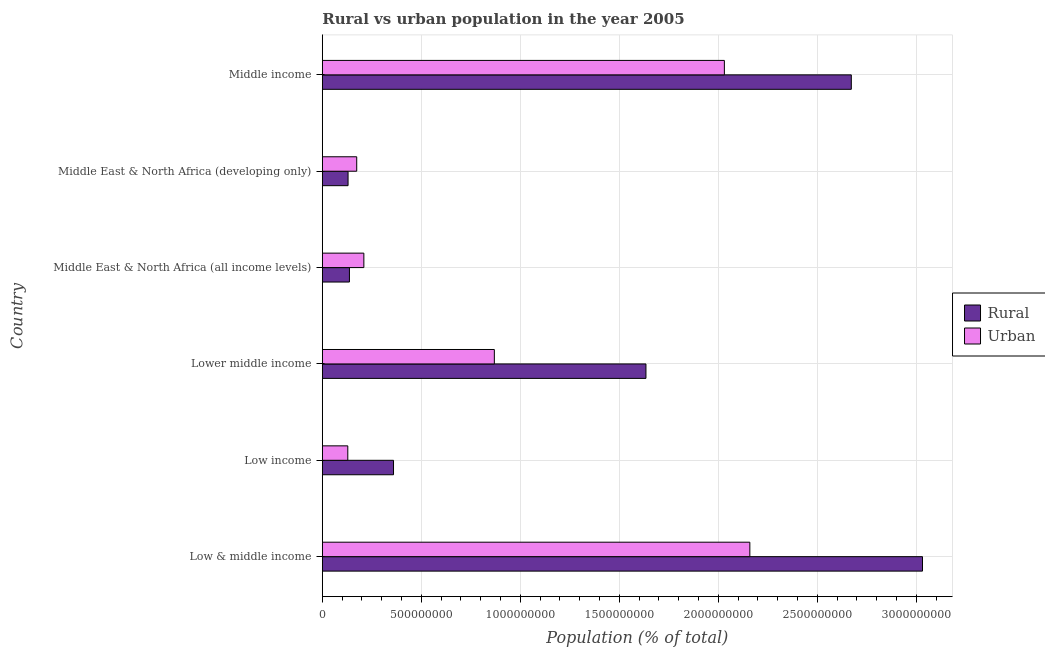Are the number of bars on each tick of the Y-axis equal?
Offer a very short reply. Yes. What is the label of the 1st group of bars from the top?
Provide a succinct answer. Middle income. In how many cases, is the number of bars for a given country not equal to the number of legend labels?
Provide a succinct answer. 0. What is the rural population density in Middle East & North Africa (developing only)?
Provide a succinct answer. 1.30e+08. Across all countries, what is the maximum rural population density?
Give a very brief answer. 3.03e+09. Across all countries, what is the minimum rural population density?
Keep it short and to the point. 1.30e+08. In which country was the rural population density maximum?
Your answer should be very brief. Low & middle income. In which country was the rural population density minimum?
Keep it short and to the point. Middle East & North Africa (developing only). What is the total urban population density in the graph?
Give a very brief answer. 5.57e+09. What is the difference between the urban population density in Low income and that in Middle East & North Africa (all income levels)?
Provide a short and direct response. -8.11e+07. What is the difference between the rural population density in Middle income and the urban population density in Lower middle income?
Offer a terse response. 1.80e+09. What is the average urban population density per country?
Provide a succinct answer. 9.28e+08. What is the difference between the rural population density and urban population density in Middle East & North Africa (developing only)?
Make the answer very short. -4.38e+07. What is the ratio of the urban population density in Middle East & North Africa (all income levels) to that in Middle East & North Africa (developing only)?
Your answer should be compact. 1.21. Is the rural population density in Low & middle income less than that in Middle East & North Africa (all income levels)?
Keep it short and to the point. No. What is the difference between the highest and the second highest rural population density?
Give a very brief answer. 3.60e+08. What is the difference between the highest and the lowest urban population density?
Offer a terse response. 2.03e+09. Is the sum of the urban population density in Lower middle income and Middle East & North Africa (developing only) greater than the maximum rural population density across all countries?
Your response must be concise. No. What does the 1st bar from the top in Low & middle income represents?
Offer a very short reply. Urban. What does the 1st bar from the bottom in Middle income represents?
Your answer should be very brief. Rural. Are the values on the major ticks of X-axis written in scientific E-notation?
Provide a short and direct response. No. Does the graph contain any zero values?
Your answer should be compact. No. Where does the legend appear in the graph?
Provide a short and direct response. Center right. How many legend labels are there?
Your answer should be very brief. 2. What is the title of the graph?
Keep it short and to the point. Rural vs urban population in the year 2005. What is the label or title of the X-axis?
Ensure brevity in your answer.  Population (% of total). What is the Population (% of total) of Rural in Low & middle income?
Keep it short and to the point. 3.03e+09. What is the Population (% of total) of Urban in Low & middle income?
Your response must be concise. 2.16e+09. What is the Population (% of total) in Rural in Low income?
Give a very brief answer. 3.60e+08. What is the Population (% of total) of Urban in Low income?
Make the answer very short. 1.29e+08. What is the Population (% of total) of Rural in Lower middle income?
Give a very brief answer. 1.63e+09. What is the Population (% of total) of Urban in Lower middle income?
Provide a short and direct response. 8.69e+08. What is the Population (% of total) of Rural in Middle East & North Africa (all income levels)?
Offer a terse response. 1.37e+08. What is the Population (% of total) of Urban in Middle East & North Africa (all income levels)?
Ensure brevity in your answer.  2.10e+08. What is the Population (% of total) in Rural in Middle East & North Africa (developing only)?
Your response must be concise. 1.30e+08. What is the Population (% of total) in Urban in Middle East & North Africa (developing only)?
Your answer should be very brief. 1.74e+08. What is the Population (% of total) of Rural in Middle income?
Provide a short and direct response. 2.67e+09. What is the Population (% of total) in Urban in Middle income?
Your answer should be very brief. 2.03e+09. Across all countries, what is the maximum Population (% of total) of Rural?
Make the answer very short. 3.03e+09. Across all countries, what is the maximum Population (% of total) of Urban?
Your answer should be very brief. 2.16e+09. Across all countries, what is the minimum Population (% of total) in Rural?
Your response must be concise. 1.30e+08. Across all countries, what is the minimum Population (% of total) of Urban?
Provide a short and direct response. 1.29e+08. What is the total Population (% of total) of Rural in the graph?
Provide a short and direct response. 7.96e+09. What is the total Population (% of total) in Urban in the graph?
Offer a terse response. 5.57e+09. What is the difference between the Population (% of total) of Rural in Low & middle income and that in Low income?
Make the answer very short. 2.67e+09. What is the difference between the Population (% of total) of Urban in Low & middle income and that in Low income?
Offer a terse response. 2.03e+09. What is the difference between the Population (% of total) in Rural in Low & middle income and that in Lower middle income?
Your response must be concise. 1.40e+09. What is the difference between the Population (% of total) in Urban in Low & middle income and that in Lower middle income?
Provide a succinct answer. 1.29e+09. What is the difference between the Population (% of total) of Rural in Low & middle income and that in Middle East & North Africa (all income levels)?
Keep it short and to the point. 2.89e+09. What is the difference between the Population (% of total) in Urban in Low & middle income and that in Middle East & North Africa (all income levels)?
Your answer should be compact. 1.95e+09. What is the difference between the Population (% of total) of Rural in Low & middle income and that in Middle East & North Africa (developing only)?
Your answer should be compact. 2.90e+09. What is the difference between the Population (% of total) in Urban in Low & middle income and that in Middle East & North Africa (developing only)?
Give a very brief answer. 1.99e+09. What is the difference between the Population (% of total) of Rural in Low & middle income and that in Middle income?
Provide a succinct answer. 3.60e+08. What is the difference between the Population (% of total) of Urban in Low & middle income and that in Middle income?
Your answer should be compact. 1.29e+08. What is the difference between the Population (% of total) in Rural in Low income and that in Lower middle income?
Ensure brevity in your answer.  -1.27e+09. What is the difference between the Population (% of total) in Urban in Low income and that in Lower middle income?
Provide a succinct answer. -7.40e+08. What is the difference between the Population (% of total) in Rural in Low income and that in Middle East & North Africa (all income levels)?
Offer a terse response. 2.23e+08. What is the difference between the Population (% of total) of Urban in Low income and that in Middle East & North Africa (all income levels)?
Ensure brevity in your answer.  -8.11e+07. What is the difference between the Population (% of total) in Rural in Low income and that in Middle East & North Africa (developing only)?
Give a very brief answer. 2.30e+08. What is the difference between the Population (% of total) of Urban in Low income and that in Middle East & North Africa (developing only)?
Provide a succinct answer. -4.51e+07. What is the difference between the Population (% of total) in Rural in Low income and that in Middle income?
Make the answer very short. -2.31e+09. What is the difference between the Population (% of total) in Urban in Low income and that in Middle income?
Your answer should be compact. -1.90e+09. What is the difference between the Population (% of total) in Rural in Lower middle income and that in Middle East & North Africa (all income levels)?
Offer a terse response. 1.50e+09. What is the difference between the Population (% of total) of Urban in Lower middle income and that in Middle East & North Africa (all income levels)?
Your answer should be compact. 6.59e+08. What is the difference between the Population (% of total) of Rural in Lower middle income and that in Middle East & North Africa (developing only)?
Your answer should be very brief. 1.50e+09. What is the difference between the Population (% of total) in Urban in Lower middle income and that in Middle East & North Africa (developing only)?
Your answer should be very brief. 6.95e+08. What is the difference between the Population (% of total) of Rural in Lower middle income and that in Middle income?
Provide a succinct answer. -1.04e+09. What is the difference between the Population (% of total) of Urban in Lower middle income and that in Middle income?
Provide a succinct answer. -1.16e+09. What is the difference between the Population (% of total) in Rural in Middle East & North Africa (all income levels) and that in Middle East & North Africa (developing only)?
Your response must be concise. 6.97e+06. What is the difference between the Population (% of total) of Urban in Middle East & North Africa (all income levels) and that in Middle East & North Africa (developing only)?
Provide a succinct answer. 3.61e+07. What is the difference between the Population (% of total) of Rural in Middle East & North Africa (all income levels) and that in Middle income?
Make the answer very short. -2.53e+09. What is the difference between the Population (% of total) in Urban in Middle East & North Africa (all income levels) and that in Middle income?
Your answer should be very brief. -1.82e+09. What is the difference between the Population (% of total) of Rural in Middle East & North Africa (developing only) and that in Middle income?
Offer a very short reply. -2.54e+09. What is the difference between the Population (% of total) of Urban in Middle East & North Africa (developing only) and that in Middle income?
Your answer should be compact. -1.86e+09. What is the difference between the Population (% of total) in Rural in Low & middle income and the Population (% of total) in Urban in Low income?
Give a very brief answer. 2.90e+09. What is the difference between the Population (% of total) of Rural in Low & middle income and the Population (% of total) of Urban in Lower middle income?
Keep it short and to the point. 2.16e+09. What is the difference between the Population (% of total) of Rural in Low & middle income and the Population (% of total) of Urban in Middle East & North Africa (all income levels)?
Provide a succinct answer. 2.82e+09. What is the difference between the Population (% of total) in Rural in Low & middle income and the Population (% of total) in Urban in Middle East & North Africa (developing only)?
Provide a succinct answer. 2.86e+09. What is the difference between the Population (% of total) of Rural in Low & middle income and the Population (% of total) of Urban in Middle income?
Ensure brevity in your answer.  1.00e+09. What is the difference between the Population (% of total) in Rural in Low income and the Population (% of total) in Urban in Lower middle income?
Keep it short and to the point. -5.09e+08. What is the difference between the Population (% of total) of Rural in Low income and the Population (% of total) of Urban in Middle East & North Africa (all income levels)?
Offer a terse response. 1.50e+08. What is the difference between the Population (% of total) in Rural in Low income and the Population (% of total) in Urban in Middle East & North Africa (developing only)?
Keep it short and to the point. 1.86e+08. What is the difference between the Population (% of total) of Rural in Low income and the Population (% of total) of Urban in Middle income?
Your response must be concise. -1.67e+09. What is the difference between the Population (% of total) in Rural in Lower middle income and the Population (% of total) in Urban in Middle East & North Africa (all income levels)?
Provide a short and direct response. 1.42e+09. What is the difference between the Population (% of total) in Rural in Lower middle income and the Population (% of total) in Urban in Middle East & North Africa (developing only)?
Give a very brief answer. 1.46e+09. What is the difference between the Population (% of total) of Rural in Lower middle income and the Population (% of total) of Urban in Middle income?
Keep it short and to the point. -3.96e+08. What is the difference between the Population (% of total) of Rural in Middle East & North Africa (all income levels) and the Population (% of total) of Urban in Middle East & North Africa (developing only)?
Offer a terse response. -3.68e+07. What is the difference between the Population (% of total) in Rural in Middle East & North Africa (all income levels) and the Population (% of total) in Urban in Middle income?
Provide a short and direct response. -1.89e+09. What is the difference between the Population (% of total) in Rural in Middle East & North Africa (developing only) and the Population (% of total) in Urban in Middle income?
Ensure brevity in your answer.  -1.90e+09. What is the average Population (% of total) in Rural per country?
Give a very brief answer. 1.33e+09. What is the average Population (% of total) in Urban per country?
Provide a succinct answer. 9.28e+08. What is the difference between the Population (% of total) in Rural and Population (% of total) in Urban in Low & middle income?
Your answer should be very brief. 8.72e+08. What is the difference between the Population (% of total) of Rural and Population (% of total) of Urban in Low income?
Make the answer very short. 2.31e+08. What is the difference between the Population (% of total) in Rural and Population (% of total) in Urban in Lower middle income?
Your response must be concise. 7.66e+08. What is the difference between the Population (% of total) of Rural and Population (% of total) of Urban in Middle East & North Africa (all income levels)?
Give a very brief answer. -7.28e+07. What is the difference between the Population (% of total) in Rural and Population (% of total) in Urban in Middle East & North Africa (developing only)?
Provide a succinct answer. -4.38e+07. What is the difference between the Population (% of total) in Rural and Population (% of total) in Urban in Middle income?
Offer a terse response. 6.41e+08. What is the ratio of the Population (% of total) of Rural in Low & middle income to that in Low income?
Offer a very short reply. 8.43. What is the ratio of the Population (% of total) in Urban in Low & middle income to that in Low income?
Keep it short and to the point. 16.78. What is the ratio of the Population (% of total) of Rural in Low & middle income to that in Lower middle income?
Your response must be concise. 1.85. What is the ratio of the Population (% of total) of Urban in Low & middle income to that in Lower middle income?
Keep it short and to the point. 2.49. What is the ratio of the Population (% of total) of Rural in Low & middle income to that in Middle East & North Africa (all income levels)?
Offer a terse response. 22.14. What is the ratio of the Population (% of total) in Urban in Low & middle income to that in Middle East & North Africa (all income levels)?
Offer a very short reply. 10.29. What is the ratio of the Population (% of total) in Rural in Low & middle income to that in Middle East & North Africa (developing only)?
Provide a succinct answer. 23.32. What is the ratio of the Population (% of total) in Urban in Low & middle income to that in Middle East & North Africa (developing only)?
Ensure brevity in your answer.  12.43. What is the ratio of the Population (% of total) of Rural in Low & middle income to that in Middle income?
Ensure brevity in your answer.  1.13. What is the ratio of the Population (% of total) in Urban in Low & middle income to that in Middle income?
Offer a terse response. 1.06. What is the ratio of the Population (% of total) in Rural in Low income to that in Lower middle income?
Your answer should be very brief. 0.22. What is the ratio of the Population (% of total) in Urban in Low income to that in Lower middle income?
Your answer should be compact. 0.15. What is the ratio of the Population (% of total) of Rural in Low income to that in Middle East & North Africa (all income levels)?
Make the answer very short. 2.63. What is the ratio of the Population (% of total) in Urban in Low income to that in Middle East & North Africa (all income levels)?
Provide a succinct answer. 0.61. What is the ratio of the Population (% of total) of Rural in Low income to that in Middle East & North Africa (developing only)?
Ensure brevity in your answer.  2.77. What is the ratio of the Population (% of total) in Urban in Low income to that in Middle East & North Africa (developing only)?
Provide a succinct answer. 0.74. What is the ratio of the Population (% of total) of Rural in Low income to that in Middle income?
Give a very brief answer. 0.13. What is the ratio of the Population (% of total) in Urban in Low income to that in Middle income?
Keep it short and to the point. 0.06. What is the ratio of the Population (% of total) in Rural in Lower middle income to that in Middle East & North Africa (all income levels)?
Provide a succinct answer. 11.94. What is the ratio of the Population (% of total) in Urban in Lower middle income to that in Middle East & North Africa (all income levels)?
Make the answer very short. 4.14. What is the ratio of the Population (% of total) of Rural in Lower middle income to that in Middle East & North Africa (developing only)?
Make the answer very short. 12.58. What is the ratio of the Population (% of total) of Urban in Lower middle income to that in Middle East & North Africa (developing only)?
Keep it short and to the point. 5. What is the ratio of the Population (% of total) of Rural in Lower middle income to that in Middle income?
Ensure brevity in your answer.  0.61. What is the ratio of the Population (% of total) of Urban in Lower middle income to that in Middle income?
Give a very brief answer. 0.43. What is the ratio of the Population (% of total) in Rural in Middle East & North Africa (all income levels) to that in Middle East & North Africa (developing only)?
Keep it short and to the point. 1.05. What is the ratio of the Population (% of total) of Urban in Middle East & North Africa (all income levels) to that in Middle East & North Africa (developing only)?
Your answer should be very brief. 1.21. What is the ratio of the Population (% of total) of Rural in Middle East & North Africa (all income levels) to that in Middle income?
Provide a short and direct response. 0.05. What is the ratio of the Population (% of total) of Urban in Middle East & North Africa (all income levels) to that in Middle income?
Give a very brief answer. 0.1. What is the ratio of the Population (% of total) in Rural in Middle East & North Africa (developing only) to that in Middle income?
Provide a succinct answer. 0.05. What is the ratio of the Population (% of total) of Urban in Middle East & North Africa (developing only) to that in Middle income?
Your answer should be very brief. 0.09. What is the difference between the highest and the second highest Population (% of total) in Rural?
Keep it short and to the point. 3.60e+08. What is the difference between the highest and the second highest Population (% of total) of Urban?
Ensure brevity in your answer.  1.29e+08. What is the difference between the highest and the lowest Population (% of total) of Rural?
Ensure brevity in your answer.  2.90e+09. What is the difference between the highest and the lowest Population (% of total) of Urban?
Provide a short and direct response. 2.03e+09. 